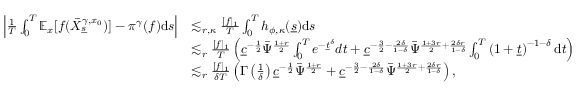Convert formula to latex. <formula><loc_0><loc_0><loc_500><loc_500>\begin{array} { r l } { \left | \frac { 1 } { T } \int _ { 0 } ^ { T } \mathbb { E } _ { x } [ f ( \bar { X } _ { \underline { s } } ^ { \gamma , x _ { 0 } } ) ] - \pi ^ { \gamma } ( f ) d s \right | } & { \lesssim _ { r , \kappa } \frac { [ f ] _ { 1 } } { T } \int _ { 0 } ^ { T } { h _ { \phi , \kappa } ( \underline { s } ) } d s } \\ & { \lesssim _ { r } \frac { [ f ] _ { 1 } } { T } \left ( \underline { c } ^ { - \frac { 1 } { 2 } } \bar { \Psi } ^ { \frac { 1 + r } { 2 } } \int _ { 0 } ^ { T } e ^ { - \underline { t } ^ { \delta } } d t + \underline { c } ^ { - \frac { 3 } { 2 } - \frac { 2 \delta } { 1 - \delta } } \bar { \Psi } ^ { \frac { 1 + 3 r } { 2 } + \frac { 2 \delta r } { 1 - \delta } } \int _ { 0 } ^ { T } \left ( 1 + \underline { t } \right ) ^ { - 1 - \delta } d t \right ) } \\ & { \lesssim _ { r } \frac { [ f ] _ { 1 } } { \delta T } \left ( \Gamma \left ( \frac { 1 } { \delta } \right ) \underline { c } ^ { - \frac { 1 } { 2 } } \bar { \Psi } ^ { \frac { 1 + r } { 2 } } + \underline { c } ^ { - \frac { 3 } { 2 } - \frac { 2 \delta } { 1 - \delta } } \bar { \Psi } ^ { \frac { 1 + 3 r } { 2 } + \frac { 2 \delta r } { 1 - \delta } } \right ) , } \end{array}</formula> 